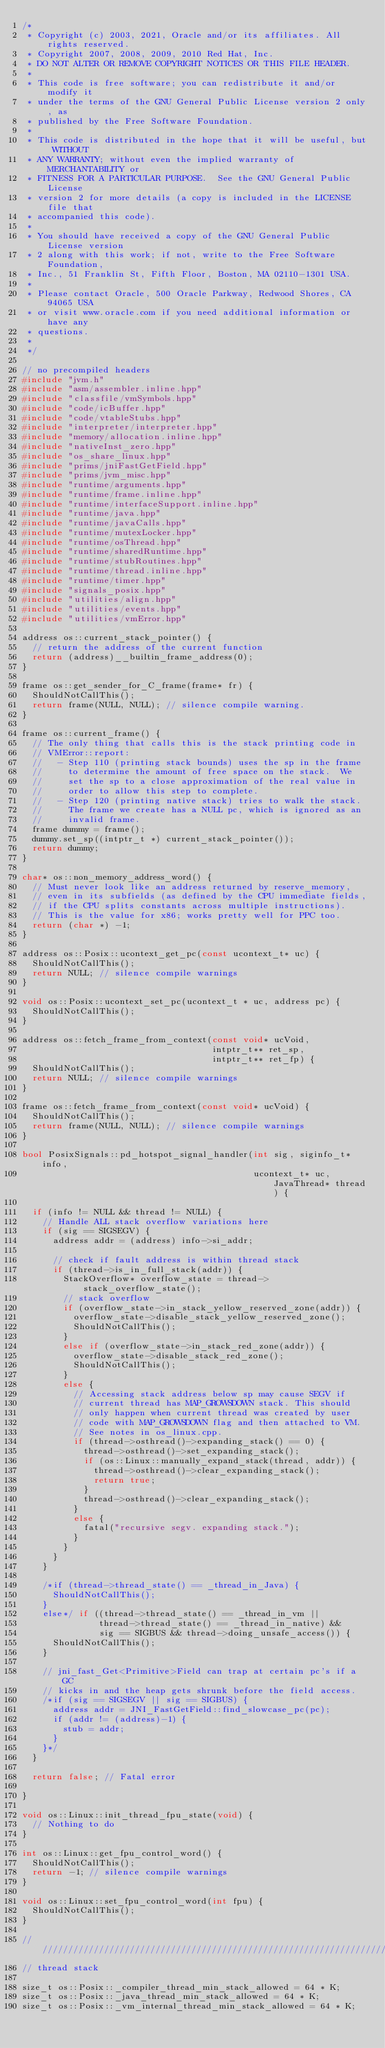<code> <loc_0><loc_0><loc_500><loc_500><_C++_>/*
 * Copyright (c) 2003, 2021, Oracle and/or its affiliates. All rights reserved.
 * Copyright 2007, 2008, 2009, 2010 Red Hat, Inc.
 * DO NOT ALTER OR REMOVE COPYRIGHT NOTICES OR THIS FILE HEADER.
 *
 * This code is free software; you can redistribute it and/or modify it
 * under the terms of the GNU General Public License version 2 only, as
 * published by the Free Software Foundation.
 *
 * This code is distributed in the hope that it will be useful, but WITHOUT
 * ANY WARRANTY; without even the implied warranty of MERCHANTABILITY or
 * FITNESS FOR A PARTICULAR PURPOSE.  See the GNU General Public License
 * version 2 for more details (a copy is included in the LICENSE file that
 * accompanied this code).
 *
 * You should have received a copy of the GNU General Public License version
 * 2 along with this work; if not, write to the Free Software Foundation,
 * Inc., 51 Franklin St, Fifth Floor, Boston, MA 02110-1301 USA.
 *
 * Please contact Oracle, 500 Oracle Parkway, Redwood Shores, CA 94065 USA
 * or visit www.oracle.com if you need additional information or have any
 * questions.
 *
 */

// no precompiled headers
#include "jvm.h"
#include "asm/assembler.inline.hpp"
#include "classfile/vmSymbols.hpp"
#include "code/icBuffer.hpp"
#include "code/vtableStubs.hpp"
#include "interpreter/interpreter.hpp"
#include "memory/allocation.inline.hpp"
#include "nativeInst_zero.hpp"
#include "os_share_linux.hpp"
#include "prims/jniFastGetField.hpp"
#include "prims/jvm_misc.hpp"
#include "runtime/arguments.hpp"
#include "runtime/frame.inline.hpp"
#include "runtime/interfaceSupport.inline.hpp"
#include "runtime/java.hpp"
#include "runtime/javaCalls.hpp"
#include "runtime/mutexLocker.hpp"
#include "runtime/osThread.hpp"
#include "runtime/sharedRuntime.hpp"
#include "runtime/stubRoutines.hpp"
#include "runtime/thread.inline.hpp"
#include "runtime/timer.hpp"
#include "signals_posix.hpp"
#include "utilities/align.hpp"
#include "utilities/events.hpp"
#include "utilities/vmError.hpp"

address os::current_stack_pointer() {
  // return the address of the current function
  return (address)__builtin_frame_address(0);
}

frame os::get_sender_for_C_frame(frame* fr) {
  ShouldNotCallThis();
  return frame(NULL, NULL); // silence compile warning.
}

frame os::current_frame() {
  // The only thing that calls this is the stack printing code in
  // VMError::report:
  //   - Step 110 (printing stack bounds) uses the sp in the frame
  //     to determine the amount of free space on the stack.  We
  //     set the sp to a close approximation of the real value in
  //     order to allow this step to complete.
  //   - Step 120 (printing native stack) tries to walk the stack.
  //     The frame we create has a NULL pc, which is ignored as an
  //     invalid frame.
  frame dummy = frame();
  dummy.set_sp((intptr_t *) current_stack_pointer());
  return dummy;
}

char* os::non_memory_address_word() {
  // Must never look like an address returned by reserve_memory,
  // even in its subfields (as defined by the CPU immediate fields,
  // if the CPU splits constants across multiple instructions).
  // This is the value for x86; works pretty well for PPC too.
  return (char *) -1;
}

address os::Posix::ucontext_get_pc(const ucontext_t* uc) {
  ShouldNotCallThis();
  return NULL; // silence compile warnings
}

void os::Posix::ucontext_set_pc(ucontext_t * uc, address pc) {
  ShouldNotCallThis();
}

address os::fetch_frame_from_context(const void* ucVoid,
                                     intptr_t** ret_sp,
                                     intptr_t** ret_fp) {
  ShouldNotCallThis();
  return NULL; // silence compile warnings
}

frame os::fetch_frame_from_context(const void* ucVoid) {
  ShouldNotCallThis();
  return frame(NULL, NULL); // silence compile warnings
}

bool PosixSignals::pd_hotspot_signal_handler(int sig, siginfo_t* info,
                                             ucontext_t* uc, JavaThread* thread) {

  if (info != NULL && thread != NULL) {
    // Handle ALL stack overflow variations here
    if (sig == SIGSEGV) {
      address addr = (address) info->si_addr;

      // check if fault address is within thread stack
      if (thread->is_in_full_stack(addr)) {
        StackOverflow* overflow_state = thread->stack_overflow_state();
        // stack overflow
        if (overflow_state->in_stack_yellow_reserved_zone(addr)) {
          overflow_state->disable_stack_yellow_reserved_zone();
          ShouldNotCallThis();
        }
        else if (overflow_state->in_stack_red_zone(addr)) {
          overflow_state->disable_stack_red_zone();
          ShouldNotCallThis();
        }
        else {
          // Accessing stack address below sp may cause SEGV if
          // current thread has MAP_GROWSDOWN stack. This should
          // only happen when current thread was created by user
          // code with MAP_GROWSDOWN flag and then attached to VM.
          // See notes in os_linux.cpp.
          if (thread->osthread()->expanding_stack() == 0) {
            thread->osthread()->set_expanding_stack();
            if (os::Linux::manually_expand_stack(thread, addr)) {
              thread->osthread()->clear_expanding_stack();
              return true;
            }
            thread->osthread()->clear_expanding_stack();
          }
          else {
            fatal("recursive segv. expanding stack.");
          }
        }
      }
    }

    /*if (thread->thread_state() == _thread_in_Java) {
      ShouldNotCallThis();
    }
    else*/ if ((thread->thread_state() == _thread_in_vm ||
               thread->thread_state() == _thread_in_native) &&
               sig == SIGBUS && thread->doing_unsafe_access()) {
      ShouldNotCallThis();
    }

    // jni_fast_Get<Primitive>Field can trap at certain pc's if a GC
    // kicks in and the heap gets shrunk before the field access.
    /*if (sig == SIGSEGV || sig == SIGBUS) {
      address addr = JNI_FastGetField::find_slowcase_pc(pc);
      if (addr != (address)-1) {
        stub = addr;
      }
    }*/
  }

  return false; // Fatal error

}

void os::Linux::init_thread_fpu_state(void) {
  // Nothing to do
}

int os::Linux::get_fpu_control_word() {
  ShouldNotCallThis();
  return -1; // silence compile warnings
}

void os::Linux::set_fpu_control_word(int fpu) {
  ShouldNotCallThis();
}

///////////////////////////////////////////////////////////////////////////////
// thread stack

size_t os::Posix::_compiler_thread_min_stack_allowed = 64 * K;
size_t os::Posix::_java_thread_min_stack_allowed = 64 * K;
size_t os::Posix::_vm_internal_thread_min_stack_allowed = 64 * K;
</code> 